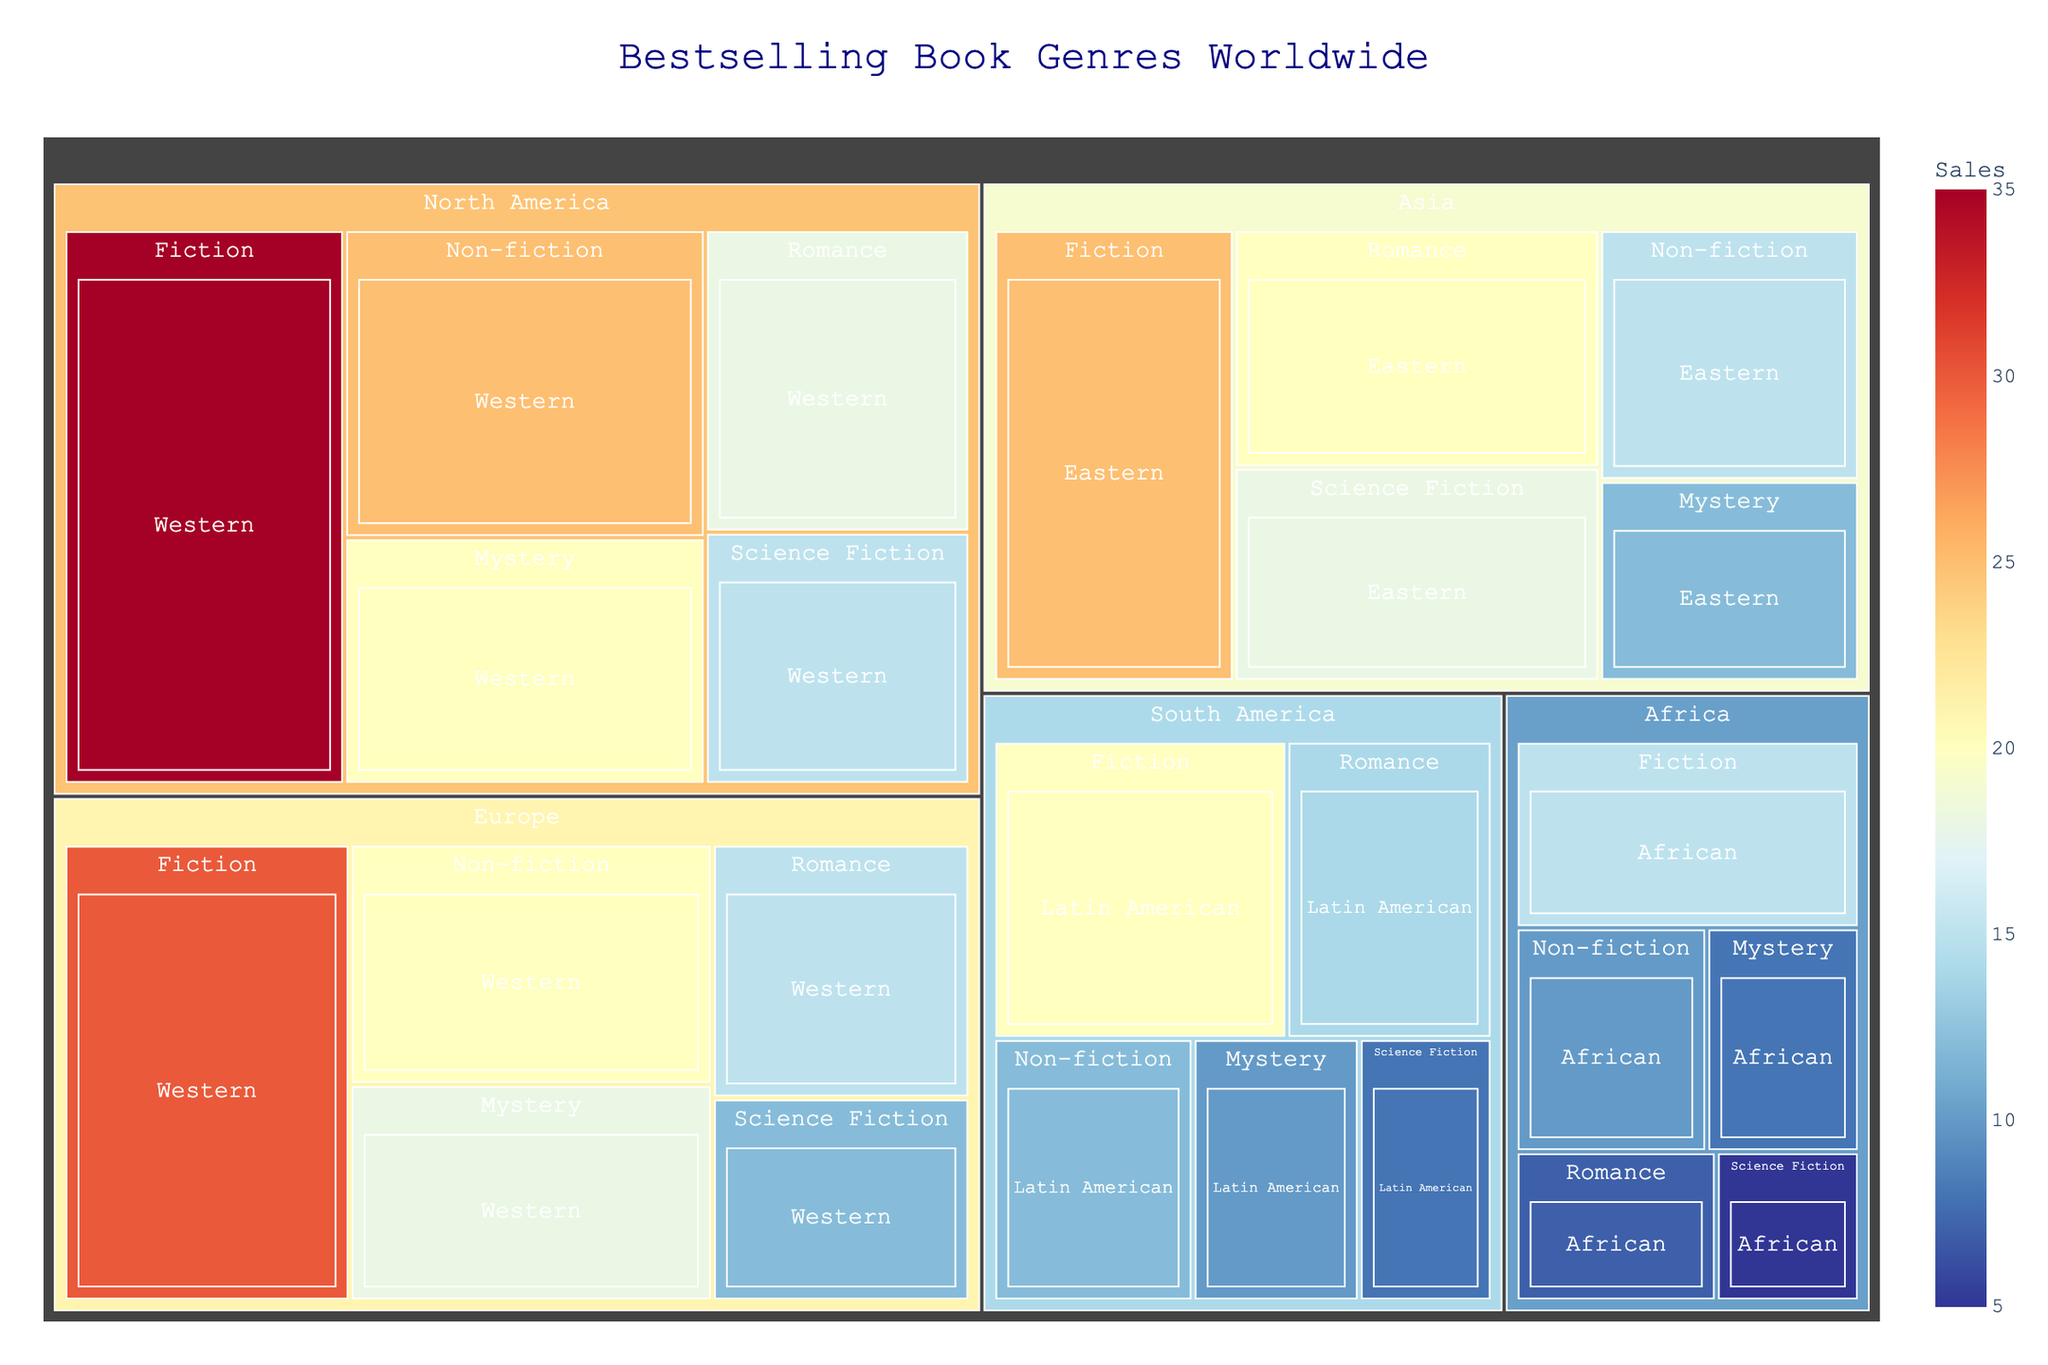What is the title of the figure? The title of the figure is the text located at the top center of the plot. This title provides a brief description of the overall content being visualized.
Answer: Bestselling Book Genres Worldwide Which region has the highest sales for Fiction? To find the region with the highest sales for Fiction, look at each block labeled "Region" under the "Fiction" genre and compare their sales numbers. The block with the largest area indicates the highest sales.
Answer: North America What are the total sales of Non-fiction books in Western cultures? Summing up the sales numbers from the Western cultures under the "Non-fiction" genre involves adding the sales from North America and Europe.
Answer: 45 Which genre has the lowest sales in Africa? To determine the genre with the lowest sales in Africa, look at the sections labeled "Africa" and compare the sales numbers for each genre.
Answer: Science Fiction How do the sales of Romance books in Asia compare with those in North America? Compare the sales numbers for Romance books in the Asia and North America regions. The sales in Asia can be directly compared to those in North America to see which is greater.
Answer: Asia has higher sales Among the listed genres, which one has the most consistent sales across all regions? To find the most consistent genre, visually compare the size of each genre's sections across all regions. A genre with similarly sized sections across all regions indicates consistency.
Answer: Fiction Which culture has the smallest sales for the Science Fiction genre? Look for the smallest block under the "Science Fiction" genre and identify its corresponding culture. The culture with the smallest area represents the smallest sales.
Answer: African What is the average sales value for the Mystery genre across all regions? Calculate the average by summing the sales for Mystery in all regions and dividing by the total number of regions (5).
Answer: 13.6 Which region has the smallest overall sales? To determine which region has the smallest overall sales, sum up the sales of all genres within each region and identify the one with the lowest total.
Answer: Africa Which genre has the most significant difference in sales between North America and South America? Compare each genre's sales between North America and South America by calculating the absolute differences and identifying the genre with the largest difference.
Answer: Fiction 